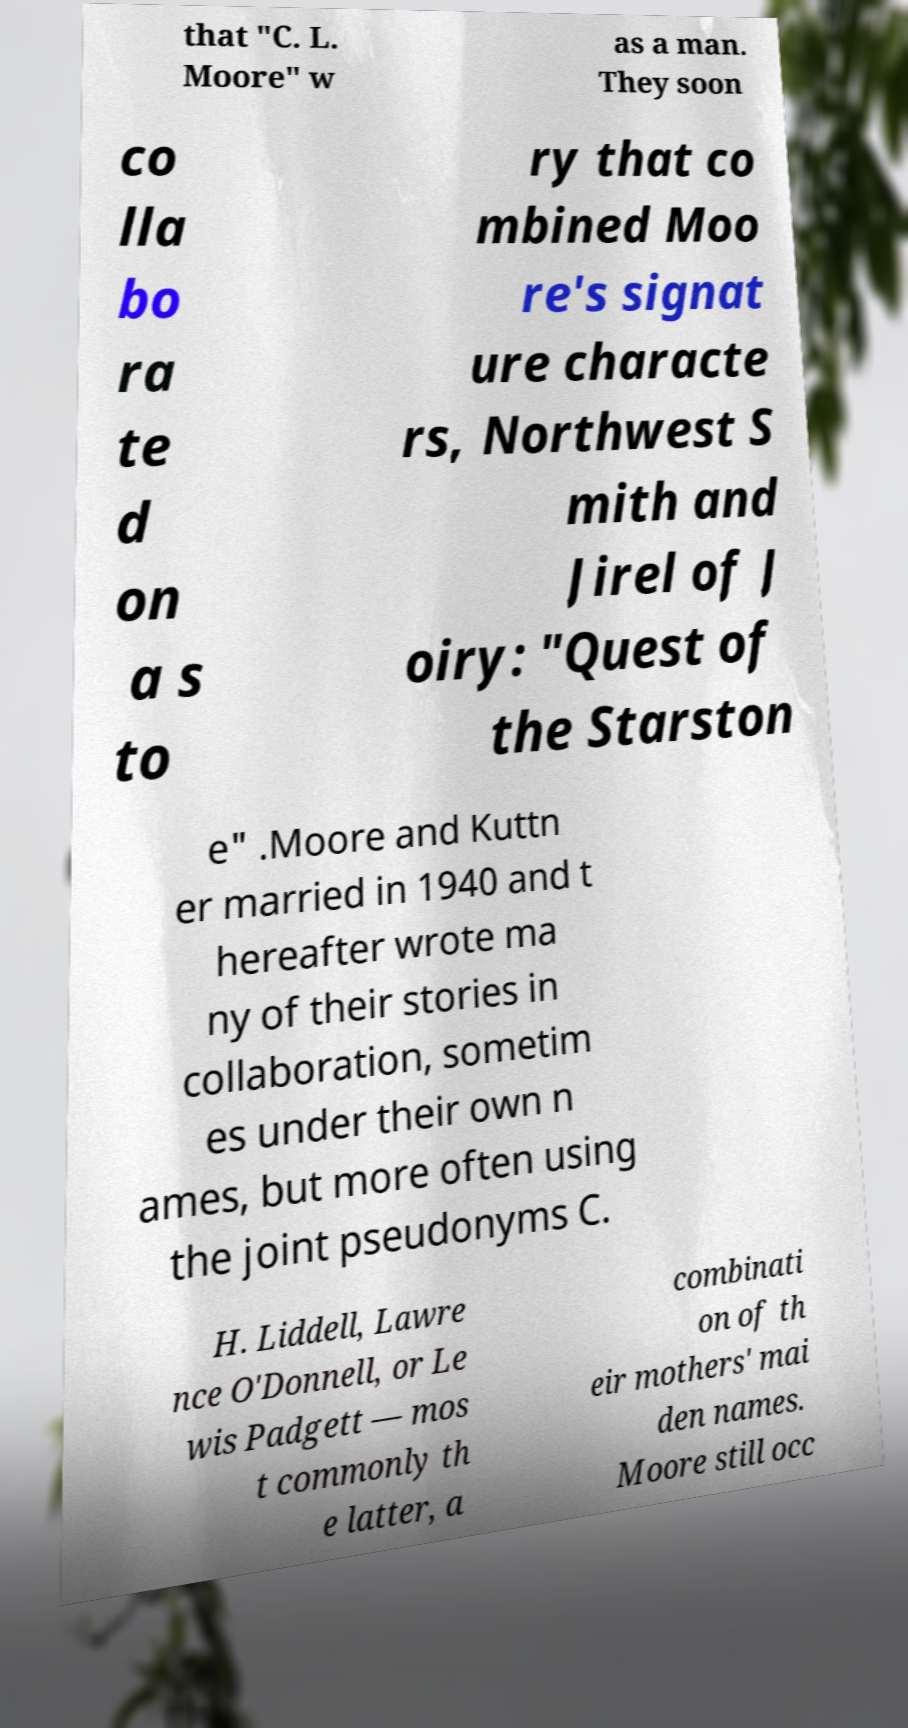Could you assist in decoding the text presented in this image and type it out clearly? that "C. L. Moore" w as a man. They soon co lla bo ra te d on a s to ry that co mbined Moo re's signat ure characte rs, Northwest S mith and Jirel of J oiry: "Quest of the Starston e" .Moore and Kuttn er married in 1940 and t hereafter wrote ma ny of their stories in collaboration, sometim es under their own n ames, but more often using the joint pseudonyms C. H. Liddell, Lawre nce O'Donnell, or Le wis Padgett — mos t commonly th e latter, a combinati on of th eir mothers' mai den names. Moore still occ 